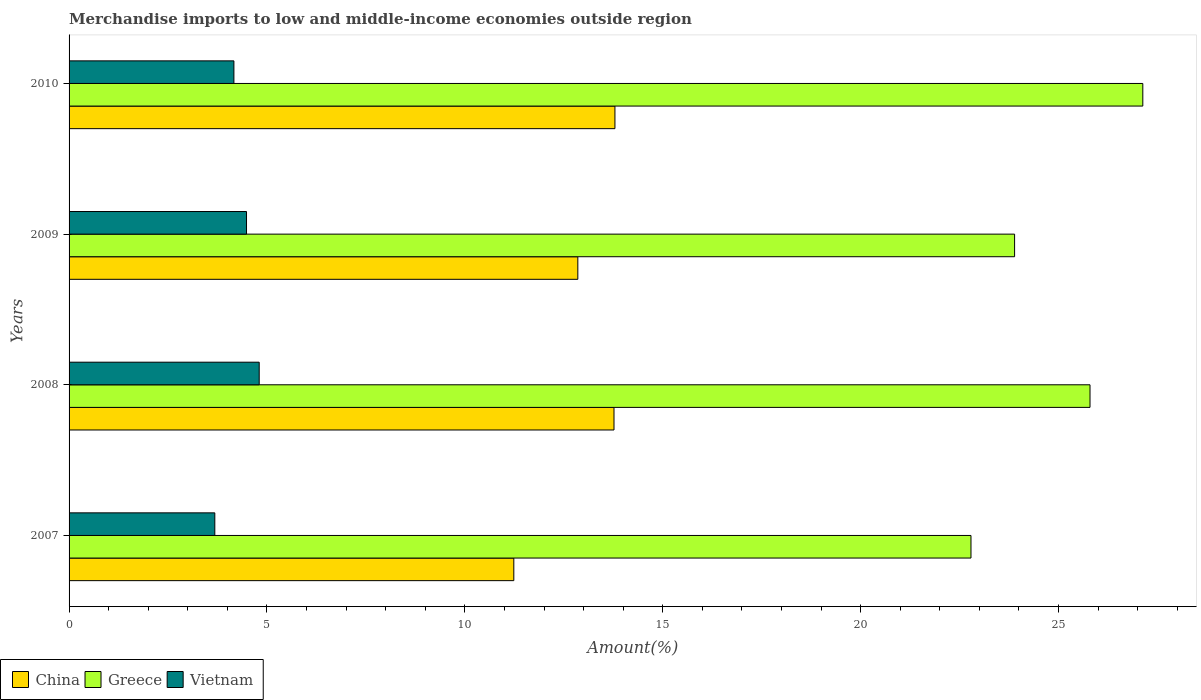Are the number of bars per tick equal to the number of legend labels?
Offer a very short reply. Yes. Are the number of bars on each tick of the Y-axis equal?
Your answer should be very brief. Yes. How many bars are there on the 4th tick from the top?
Your response must be concise. 3. What is the label of the 1st group of bars from the top?
Offer a very short reply. 2010. What is the percentage of amount earned from merchandise imports in Vietnam in 2008?
Make the answer very short. 4.8. Across all years, what is the maximum percentage of amount earned from merchandise imports in Greece?
Your answer should be compact. 27.13. Across all years, what is the minimum percentage of amount earned from merchandise imports in Vietnam?
Your answer should be very brief. 3.68. What is the total percentage of amount earned from merchandise imports in China in the graph?
Your response must be concise. 51.65. What is the difference between the percentage of amount earned from merchandise imports in Vietnam in 2008 and that in 2009?
Your response must be concise. 0.32. What is the difference between the percentage of amount earned from merchandise imports in Greece in 2009 and the percentage of amount earned from merchandise imports in Vietnam in 2008?
Give a very brief answer. 19.09. What is the average percentage of amount earned from merchandise imports in Vietnam per year?
Your response must be concise. 4.28. In the year 2009, what is the difference between the percentage of amount earned from merchandise imports in Vietnam and percentage of amount earned from merchandise imports in China?
Your answer should be very brief. -8.37. In how many years, is the percentage of amount earned from merchandise imports in Greece greater than 6 %?
Your answer should be very brief. 4. What is the ratio of the percentage of amount earned from merchandise imports in Vietnam in 2007 to that in 2008?
Ensure brevity in your answer.  0.77. Is the difference between the percentage of amount earned from merchandise imports in Vietnam in 2007 and 2008 greater than the difference between the percentage of amount earned from merchandise imports in China in 2007 and 2008?
Your answer should be very brief. Yes. What is the difference between the highest and the second highest percentage of amount earned from merchandise imports in Vietnam?
Provide a short and direct response. 0.32. What is the difference between the highest and the lowest percentage of amount earned from merchandise imports in Greece?
Provide a short and direct response. 4.34. In how many years, is the percentage of amount earned from merchandise imports in Vietnam greater than the average percentage of amount earned from merchandise imports in Vietnam taken over all years?
Your answer should be very brief. 2. What does the 2nd bar from the top in 2008 represents?
Keep it short and to the point. Greece. What does the 3rd bar from the bottom in 2007 represents?
Your answer should be compact. Vietnam. Are all the bars in the graph horizontal?
Your response must be concise. Yes. Does the graph contain grids?
Make the answer very short. No. How many legend labels are there?
Give a very brief answer. 3. How are the legend labels stacked?
Make the answer very short. Horizontal. What is the title of the graph?
Your response must be concise. Merchandise imports to low and middle-income economies outside region. What is the label or title of the X-axis?
Provide a succinct answer. Amount(%). What is the label or title of the Y-axis?
Provide a succinct answer. Years. What is the Amount(%) of China in 2007?
Your response must be concise. 11.24. What is the Amount(%) in Greece in 2007?
Give a very brief answer. 22.79. What is the Amount(%) in Vietnam in 2007?
Offer a terse response. 3.68. What is the Amount(%) in China in 2008?
Your answer should be compact. 13.77. What is the Amount(%) in Greece in 2008?
Your answer should be very brief. 25.79. What is the Amount(%) of Vietnam in 2008?
Your answer should be very brief. 4.8. What is the Amount(%) of China in 2009?
Your response must be concise. 12.85. What is the Amount(%) in Greece in 2009?
Offer a very short reply. 23.89. What is the Amount(%) in Vietnam in 2009?
Your response must be concise. 4.48. What is the Amount(%) in China in 2010?
Provide a short and direct response. 13.79. What is the Amount(%) in Greece in 2010?
Ensure brevity in your answer.  27.13. What is the Amount(%) in Vietnam in 2010?
Your response must be concise. 4.16. Across all years, what is the maximum Amount(%) of China?
Your answer should be very brief. 13.79. Across all years, what is the maximum Amount(%) in Greece?
Keep it short and to the point. 27.13. Across all years, what is the maximum Amount(%) in Vietnam?
Keep it short and to the point. 4.8. Across all years, what is the minimum Amount(%) in China?
Your answer should be very brief. 11.24. Across all years, what is the minimum Amount(%) of Greece?
Make the answer very short. 22.79. Across all years, what is the minimum Amount(%) in Vietnam?
Offer a terse response. 3.68. What is the total Amount(%) of China in the graph?
Make the answer very short. 51.65. What is the total Amount(%) of Greece in the graph?
Ensure brevity in your answer.  99.6. What is the total Amount(%) of Vietnam in the graph?
Your response must be concise. 17.13. What is the difference between the Amount(%) of China in 2007 and that in 2008?
Give a very brief answer. -2.53. What is the difference between the Amount(%) of Greece in 2007 and that in 2008?
Provide a succinct answer. -3.01. What is the difference between the Amount(%) of Vietnam in 2007 and that in 2008?
Your answer should be very brief. -1.12. What is the difference between the Amount(%) in China in 2007 and that in 2009?
Your response must be concise. -1.62. What is the difference between the Amount(%) in Greece in 2007 and that in 2009?
Give a very brief answer. -1.1. What is the difference between the Amount(%) in Vietnam in 2007 and that in 2009?
Keep it short and to the point. -0.8. What is the difference between the Amount(%) of China in 2007 and that in 2010?
Ensure brevity in your answer.  -2.55. What is the difference between the Amount(%) in Greece in 2007 and that in 2010?
Offer a terse response. -4.34. What is the difference between the Amount(%) of Vietnam in 2007 and that in 2010?
Offer a terse response. -0.48. What is the difference between the Amount(%) in China in 2008 and that in 2009?
Give a very brief answer. 0.91. What is the difference between the Amount(%) of Greece in 2008 and that in 2009?
Your answer should be very brief. 1.91. What is the difference between the Amount(%) in Vietnam in 2008 and that in 2009?
Ensure brevity in your answer.  0.32. What is the difference between the Amount(%) of China in 2008 and that in 2010?
Keep it short and to the point. -0.02. What is the difference between the Amount(%) of Greece in 2008 and that in 2010?
Provide a short and direct response. -1.33. What is the difference between the Amount(%) in Vietnam in 2008 and that in 2010?
Ensure brevity in your answer.  0.64. What is the difference between the Amount(%) of China in 2009 and that in 2010?
Ensure brevity in your answer.  -0.94. What is the difference between the Amount(%) in Greece in 2009 and that in 2010?
Make the answer very short. -3.24. What is the difference between the Amount(%) in Vietnam in 2009 and that in 2010?
Offer a terse response. 0.32. What is the difference between the Amount(%) of China in 2007 and the Amount(%) of Greece in 2008?
Keep it short and to the point. -14.56. What is the difference between the Amount(%) in China in 2007 and the Amount(%) in Vietnam in 2008?
Make the answer very short. 6.43. What is the difference between the Amount(%) in Greece in 2007 and the Amount(%) in Vietnam in 2008?
Provide a short and direct response. 17.98. What is the difference between the Amount(%) in China in 2007 and the Amount(%) in Greece in 2009?
Give a very brief answer. -12.65. What is the difference between the Amount(%) in China in 2007 and the Amount(%) in Vietnam in 2009?
Your answer should be compact. 6.75. What is the difference between the Amount(%) of Greece in 2007 and the Amount(%) of Vietnam in 2009?
Your answer should be compact. 18.3. What is the difference between the Amount(%) in China in 2007 and the Amount(%) in Greece in 2010?
Offer a very short reply. -15.89. What is the difference between the Amount(%) of China in 2007 and the Amount(%) of Vietnam in 2010?
Provide a succinct answer. 7.07. What is the difference between the Amount(%) of Greece in 2007 and the Amount(%) of Vietnam in 2010?
Your answer should be very brief. 18.62. What is the difference between the Amount(%) in China in 2008 and the Amount(%) in Greece in 2009?
Your answer should be compact. -10.12. What is the difference between the Amount(%) in China in 2008 and the Amount(%) in Vietnam in 2009?
Offer a terse response. 9.28. What is the difference between the Amount(%) in Greece in 2008 and the Amount(%) in Vietnam in 2009?
Provide a succinct answer. 21.31. What is the difference between the Amount(%) of China in 2008 and the Amount(%) of Greece in 2010?
Your answer should be compact. -13.36. What is the difference between the Amount(%) of China in 2008 and the Amount(%) of Vietnam in 2010?
Ensure brevity in your answer.  9.6. What is the difference between the Amount(%) in Greece in 2008 and the Amount(%) in Vietnam in 2010?
Make the answer very short. 21.63. What is the difference between the Amount(%) in China in 2009 and the Amount(%) in Greece in 2010?
Your answer should be compact. -14.27. What is the difference between the Amount(%) in China in 2009 and the Amount(%) in Vietnam in 2010?
Your answer should be very brief. 8.69. What is the difference between the Amount(%) of Greece in 2009 and the Amount(%) of Vietnam in 2010?
Your response must be concise. 19.72. What is the average Amount(%) in China per year?
Your answer should be very brief. 12.91. What is the average Amount(%) of Greece per year?
Ensure brevity in your answer.  24.9. What is the average Amount(%) in Vietnam per year?
Your answer should be very brief. 4.28. In the year 2007, what is the difference between the Amount(%) in China and Amount(%) in Greece?
Your answer should be compact. -11.55. In the year 2007, what is the difference between the Amount(%) in China and Amount(%) in Vietnam?
Give a very brief answer. 7.55. In the year 2007, what is the difference between the Amount(%) in Greece and Amount(%) in Vietnam?
Provide a short and direct response. 19.1. In the year 2008, what is the difference between the Amount(%) in China and Amount(%) in Greece?
Provide a short and direct response. -12.03. In the year 2008, what is the difference between the Amount(%) in China and Amount(%) in Vietnam?
Ensure brevity in your answer.  8.96. In the year 2008, what is the difference between the Amount(%) of Greece and Amount(%) of Vietnam?
Offer a very short reply. 20.99. In the year 2009, what is the difference between the Amount(%) in China and Amount(%) in Greece?
Provide a short and direct response. -11.04. In the year 2009, what is the difference between the Amount(%) in China and Amount(%) in Vietnam?
Make the answer very short. 8.37. In the year 2009, what is the difference between the Amount(%) of Greece and Amount(%) of Vietnam?
Offer a terse response. 19.41. In the year 2010, what is the difference between the Amount(%) in China and Amount(%) in Greece?
Give a very brief answer. -13.34. In the year 2010, what is the difference between the Amount(%) in China and Amount(%) in Vietnam?
Provide a succinct answer. 9.63. In the year 2010, what is the difference between the Amount(%) in Greece and Amount(%) in Vietnam?
Ensure brevity in your answer.  22.96. What is the ratio of the Amount(%) of China in 2007 to that in 2008?
Your response must be concise. 0.82. What is the ratio of the Amount(%) of Greece in 2007 to that in 2008?
Provide a succinct answer. 0.88. What is the ratio of the Amount(%) of Vietnam in 2007 to that in 2008?
Give a very brief answer. 0.77. What is the ratio of the Amount(%) of China in 2007 to that in 2009?
Offer a terse response. 0.87. What is the ratio of the Amount(%) of Greece in 2007 to that in 2009?
Give a very brief answer. 0.95. What is the ratio of the Amount(%) in Vietnam in 2007 to that in 2009?
Ensure brevity in your answer.  0.82. What is the ratio of the Amount(%) of China in 2007 to that in 2010?
Your answer should be very brief. 0.81. What is the ratio of the Amount(%) of Greece in 2007 to that in 2010?
Your answer should be very brief. 0.84. What is the ratio of the Amount(%) of Vietnam in 2007 to that in 2010?
Give a very brief answer. 0.88. What is the ratio of the Amount(%) of China in 2008 to that in 2009?
Give a very brief answer. 1.07. What is the ratio of the Amount(%) in Greece in 2008 to that in 2009?
Ensure brevity in your answer.  1.08. What is the ratio of the Amount(%) in Vietnam in 2008 to that in 2009?
Make the answer very short. 1.07. What is the ratio of the Amount(%) in Greece in 2008 to that in 2010?
Provide a short and direct response. 0.95. What is the ratio of the Amount(%) in Vietnam in 2008 to that in 2010?
Keep it short and to the point. 1.15. What is the ratio of the Amount(%) in China in 2009 to that in 2010?
Provide a succinct answer. 0.93. What is the ratio of the Amount(%) of Greece in 2009 to that in 2010?
Ensure brevity in your answer.  0.88. What is the ratio of the Amount(%) in Vietnam in 2009 to that in 2010?
Give a very brief answer. 1.08. What is the difference between the highest and the second highest Amount(%) of China?
Provide a short and direct response. 0.02. What is the difference between the highest and the second highest Amount(%) of Greece?
Your answer should be very brief. 1.33. What is the difference between the highest and the second highest Amount(%) of Vietnam?
Ensure brevity in your answer.  0.32. What is the difference between the highest and the lowest Amount(%) of China?
Your answer should be compact. 2.55. What is the difference between the highest and the lowest Amount(%) of Greece?
Make the answer very short. 4.34. What is the difference between the highest and the lowest Amount(%) of Vietnam?
Offer a terse response. 1.12. 